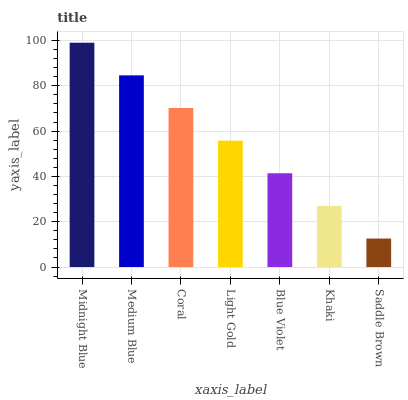Is Saddle Brown the minimum?
Answer yes or no. Yes. Is Midnight Blue the maximum?
Answer yes or no. Yes. Is Medium Blue the minimum?
Answer yes or no. No. Is Medium Blue the maximum?
Answer yes or no. No. Is Midnight Blue greater than Medium Blue?
Answer yes or no. Yes. Is Medium Blue less than Midnight Blue?
Answer yes or no. Yes. Is Medium Blue greater than Midnight Blue?
Answer yes or no. No. Is Midnight Blue less than Medium Blue?
Answer yes or no. No. Is Light Gold the high median?
Answer yes or no. Yes. Is Light Gold the low median?
Answer yes or no. Yes. Is Coral the high median?
Answer yes or no. No. Is Medium Blue the low median?
Answer yes or no. No. 